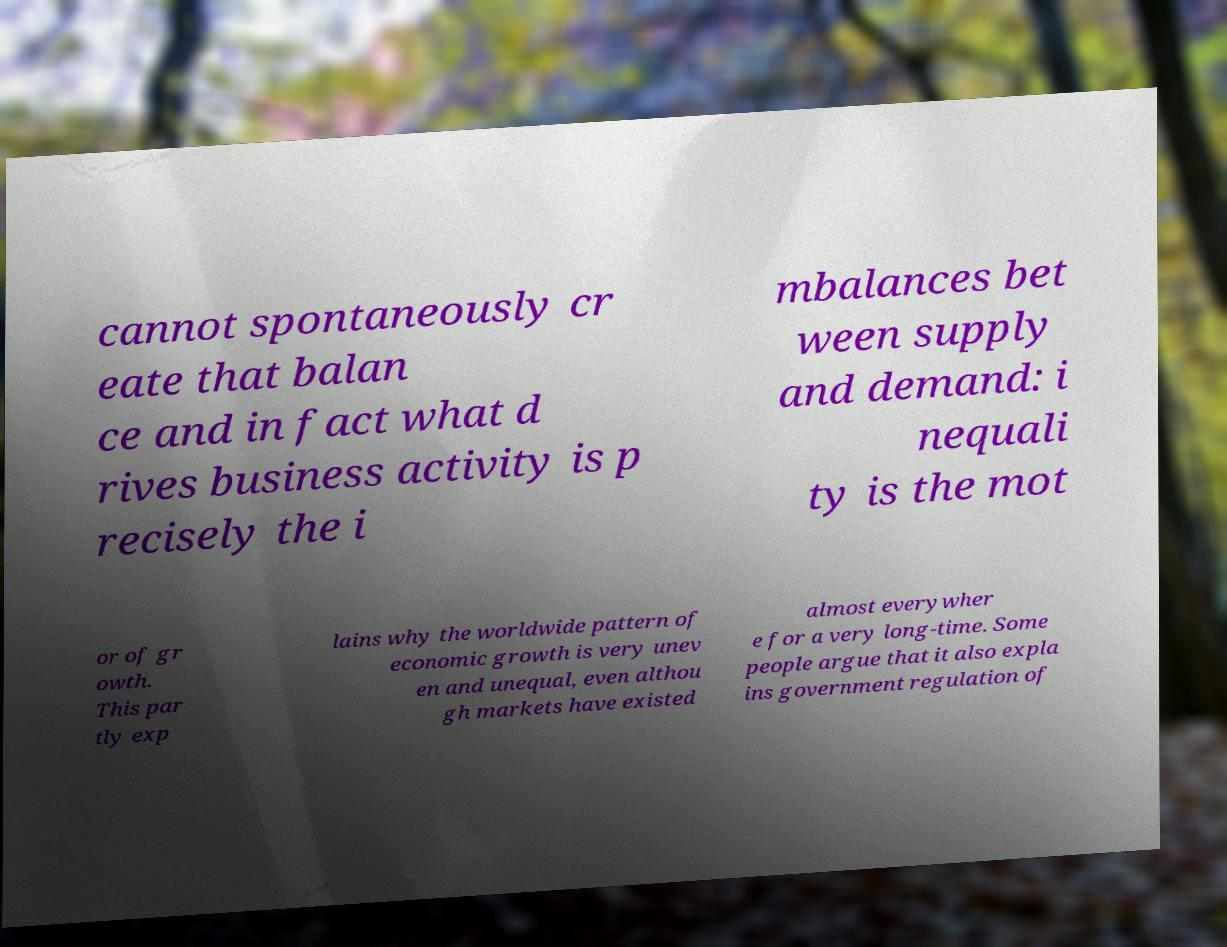Can you read and provide the text displayed in the image?This photo seems to have some interesting text. Can you extract and type it out for me? cannot spontaneously cr eate that balan ce and in fact what d rives business activity is p recisely the i mbalances bet ween supply and demand: i nequali ty is the mot or of gr owth. This par tly exp lains why the worldwide pattern of economic growth is very unev en and unequal, even althou gh markets have existed almost everywher e for a very long-time. Some people argue that it also expla ins government regulation of 